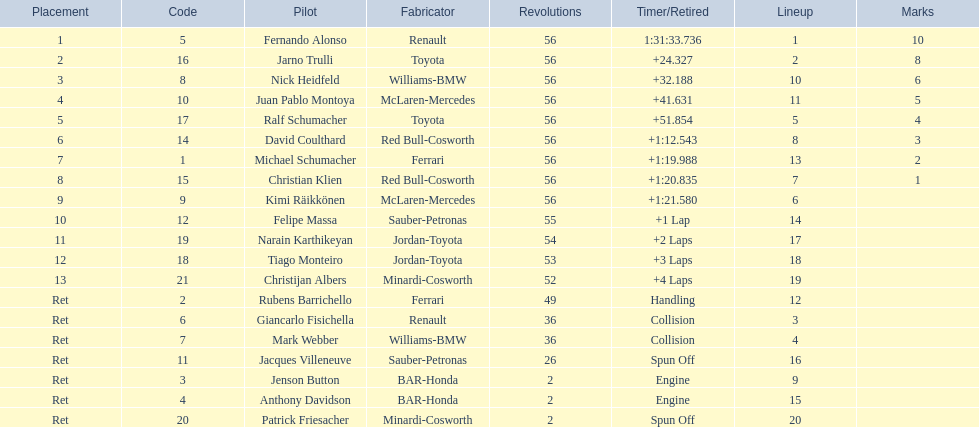How long did it take for heidfeld to finish? 1:31:65.924. 